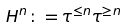Convert formula to latex. <formula><loc_0><loc_0><loc_500><loc_500>H ^ { n } \colon = \tau ^ { \leq n } \tau ^ { \geq n }</formula> 